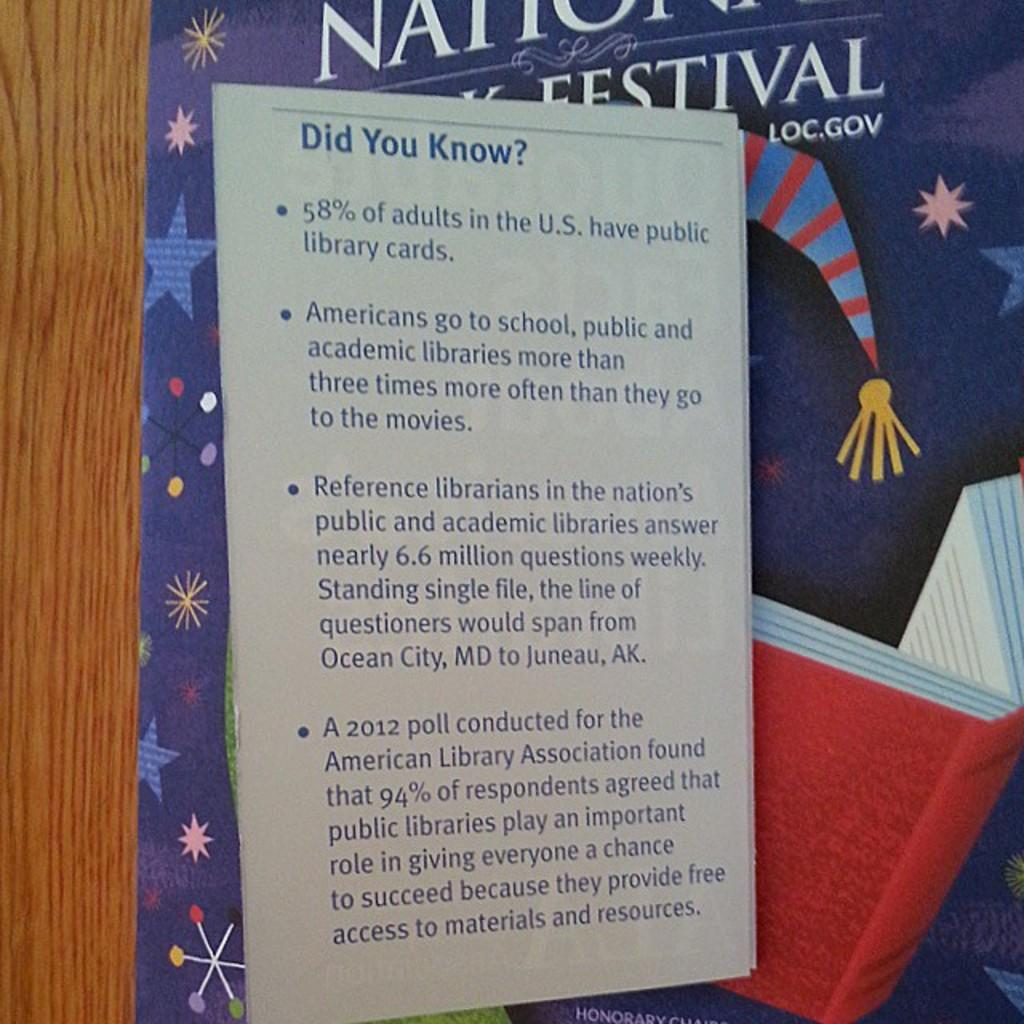<image>
Create a compact narrative representing the image presented. A panel titled Did You Know? with information about public libraries. 